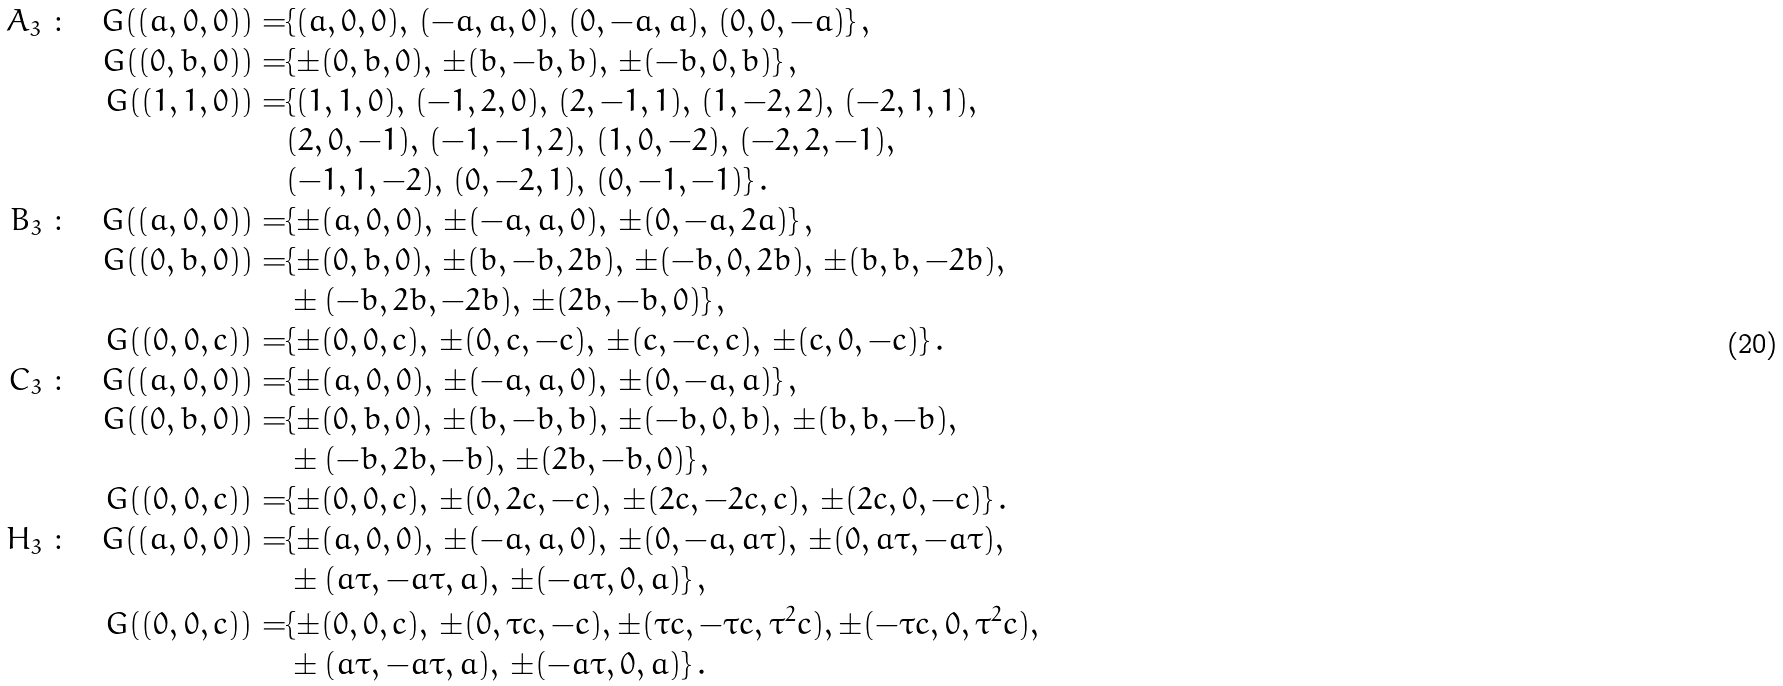<formula> <loc_0><loc_0><loc_500><loc_500>A _ { 3 } \ \colon \quad G ( ( a , 0 , 0 ) ) = & \{ ( a , 0 , 0 ) , \, ( - a , a , 0 ) , \, ( 0 , - a , a ) , \, ( 0 , 0 , - a ) \} \, , \\ G ( ( 0 , b , 0 ) ) = & \{ \pm ( 0 , b , 0 ) , \, \pm ( b , - b , b ) , \, \pm ( - b , 0 , b ) \} \, , \\ G ( ( 1 , 1 , 0 ) ) = & \{ ( 1 , 1 , 0 ) , \, ( - 1 , 2 , 0 ) , \, ( 2 , - 1 , 1 ) , \, ( 1 , - 2 , 2 ) , \, ( - 2 , 1 , 1 ) , \, \\ & ( 2 , 0 , - 1 ) , \, ( - 1 , - 1 , 2 ) , \, ( 1 , 0 , - 2 ) , \, ( - 2 , 2 , - 1 ) , \, \\ & ( - 1 , 1 , - 2 ) , \, ( 0 , - 2 , 1 ) , \, ( 0 , - 1 , - 1 ) \} \, . \\ B _ { 3 } \ \colon \quad G ( ( a , 0 , 0 ) ) = & \{ \pm ( a , 0 , 0 ) , \, \pm ( - a , a , 0 ) , \, \pm ( 0 , - a , 2 a ) \} \, , \\ G ( ( 0 , b , 0 ) ) = & \{ \pm ( 0 , b , 0 ) , \, \pm ( b , - b , 2 b ) , \, \pm ( - b , 0 , 2 b ) , \, \pm ( b , b , - 2 b ) , \, \\ & \pm ( - b , 2 b , - 2 b ) , \, \pm ( 2 b , - b , 0 ) \} \, , \\ G ( ( 0 , 0 , c ) ) = & \{ \pm ( 0 , 0 , c ) , \, \pm ( 0 , c , - c ) , \, \pm ( c , - c , c ) , \, \pm ( c , 0 , - c ) \} \, . \\ C _ { 3 } \ \colon \quad G ( ( a , 0 , 0 ) ) = & \{ \pm ( a , 0 , 0 ) , \, \pm ( - a , a , 0 ) , \, \pm ( 0 , - a , a ) \} \, , \\ G ( ( 0 , b , 0 ) ) = & \{ \pm ( 0 , b , 0 ) , \, \pm ( b , - b , b ) , \, \pm ( - b , 0 , b ) , \, \pm ( b , b , - b ) , \, \\ & \pm ( - b , 2 b , - b ) , \, \pm ( 2 b , - b , 0 ) \} \, , \\ G ( ( 0 , 0 , c ) ) = & \{ \pm ( 0 , 0 , c ) , \, \pm ( 0 , 2 c , - c ) , \, \pm ( 2 c , - 2 c , c ) , \, \pm ( 2 c , 0 , - c ) \} \, . \\ H _ { 3 } \ \colon \quad G ( ( a , 0 , 0 ) ) = & \{ \pm ( a , 0 , 0 ) , \, \pm ( - a , a , 0 ) , \, \pm ( 0 , - a , a \tau ) , \, \pm ( 0 , a \tau , - a \tau ) , \\ & \pm ( a \tau , - a \tau , a ) , \, \pm ( - a \tau , 0 , a ) \} \, , \\ G ( ( 0 , 0 , c ) ) = & \{ \pm ( 0 , 0 , c ) , \, \pm ( 0 , \tau c , - c ) , \pm ( \tau c , - \tau c , \tau ^ { 2 } c ) , \pm ( - \tau c , 0 , \tau ^ { 2 } c ) , \\ & \pm ( a \tau , - a \tau , a ) , \, \pm ( - a \tau , 0 , a ) \} \, .</formula> 